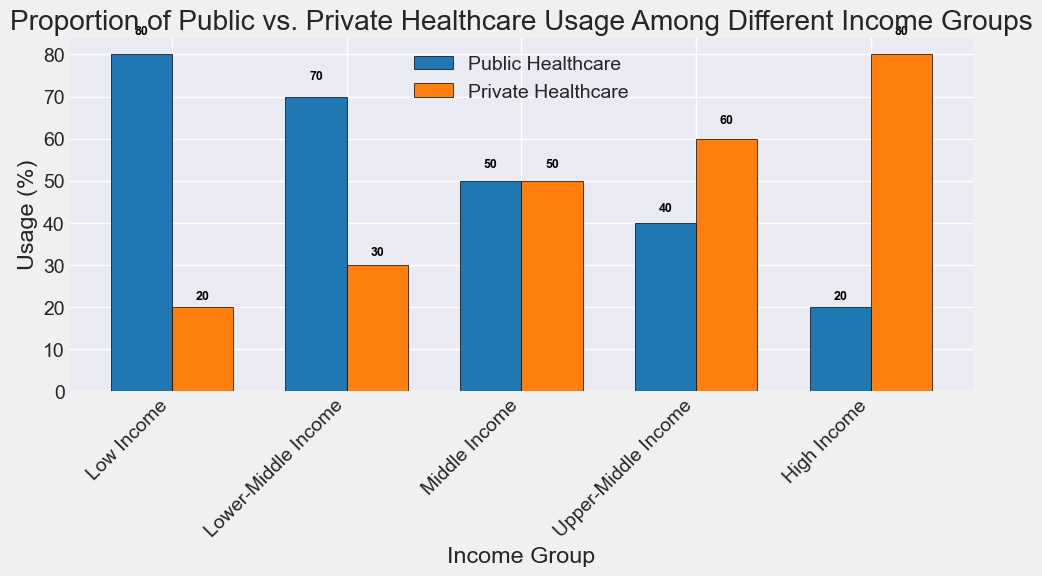Which income group uses public healthcare the most? The figure shows that the "Low Income" group uses public healthcare the most, with an 80% usage rate.
Answer: Low Income What's the difference in public healthcare usage between the Low Income and High Income groups? The figure indicates that the Low Income group has 80% public healthcare usage, while the High Income group has 20%. The difference is 80% - 20% = 60%.
Answer: 60% In which income group is the usage of private healthcare and public healthcare equal? The figure shows that the "Middle Income" group has equal proportions of public and private healthcare usage, both at 50%.
Answer: Middle Income What is the total percentage of private healthcare usage for the Lower-Middle Income and High Income groups combined? From the figure, Lower-Middle Income has 30% private usage, and High Income has 80%. Adding these, 30% + 80% = 110%.
Answer: 110% Which income group has the smallest proportion of private healthcare usage? The figure indicates that the group with the lowest private healthcare usage is the "Low Income" group, with a 20% usage rate.
Answer: Low Income Identify the income group with the most significant disparity between public and private healthcare usage. The figure shows that the "High Income" group has the greatest difference, with 20% public and 80% private usage, a disparity of 60%.
Answer: High Income How much higher is public healthcare usage for the Upper-Middle Income group compared to the High Income group? From the figure, the Upper-Middle Income group has 40% public usage, and the High Income group has 20%. The difference is 40% - 20% = 20%.
Answer: 20% What is the average percentage of private healthcare usage across all income groups? Add all the private usage percentages from the figure: 20% (Low Income) + 30% (Lower-Middle Income) + 50% (Middle Income) + 60% (Upper-Middle Income) + 80% (High Income) = 240%. There are 5 groups, so average is 240% / 5 = 48%.
Answer: 48% Which bar color represents public healthcare usage? The visual attribute of the figure shows that the bars representing public healthcare are colored blue.
Answer: Blue 